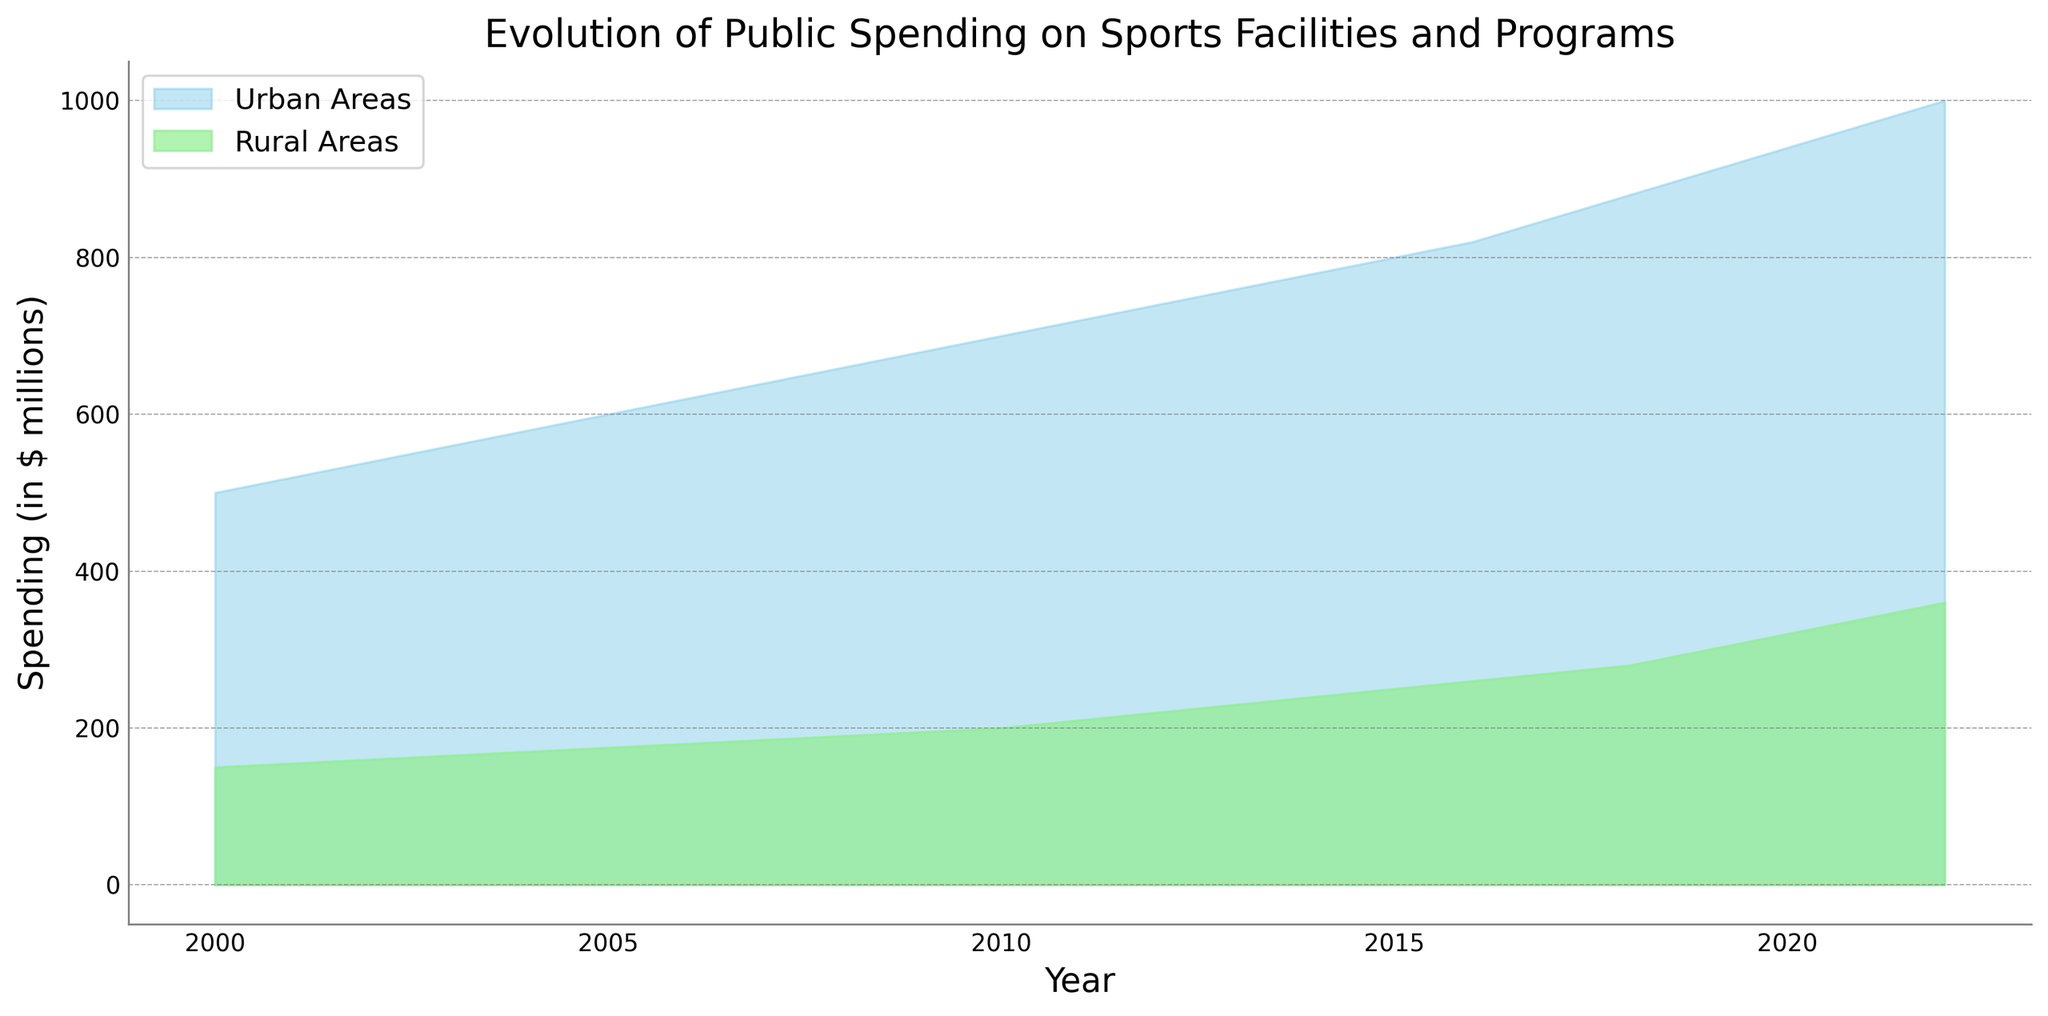What is the title of the plot? The title is displayed at the top of the plot and is typically larger in font size.
Answer: Evolution of Public Spending on Sports Facilities and Programs Which area has shown a steeper increase in spending, Urban or Rural? By observing the slopes, Urban Areas show a steeper increase since the area representing the Urban data ascends more sharply over the years compared to Rural Areas.
Answer: Urban Areas What was the spending on sports facilities and programs in Rural Areas in 2010? Locate the 2010 value on the x-axis and look upwards to the green area representing Rural spending.
Answer: 200 million In which year did the spending in Urban Areas reach 800 million? Find the point where the blue area reaches 800 on the y-axis and trace it down to the corresponding year on the x-axis.
Answer: 2015 Between which years did the spending in Rural Areas go from 210 million to 360 million? Identify the years associated with the spending values of 210 and 360 million in the Rural Area section (green area).
Answer: 2011 to 2022 By how much did the spending in Urban Areas increase between 2000 and 2010? Subtract the value of 500 million in 2000 from 700 million in 2010 to find the difference.
Answer: 200 million What is the color used to represent the Rural Areas in the chart? Identify the color filling the area associated with Rural Areas.
Answer: Light green Which year had the smallest gap between Urban and Rural spending? Compare the difference between the two areas for each year by observing the vertical distances. 2000 has the smallest gap with 350 million.
Answer: 2000 In what year did Rural Areas cross the 300 million spending mark? Locate the point in the green area that first crosses the 300 million mark and trace it vertically to see the corresponding year.
Answer: 2019 What's the difference in spending between Urban and Rural Areas in 2022? Find the values for both Urban (1000 million) and Rural (360 million) in 2022 and subtract the Rural spending from the Urban spending.
Answer: 640 million 